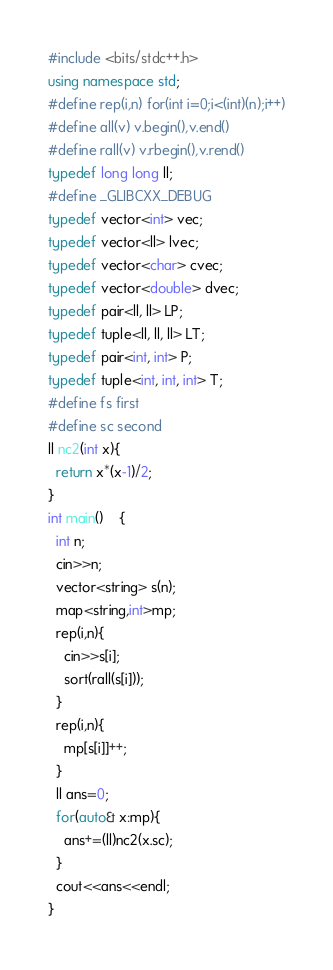<code> <loc_0><loc_0><loc_500><loc_500><_C++_>#include <bits/stdc++.h>
using namespace std;
#define rep(i,n) for(int i=0;i<(int)(n);i++)
#define all(v) v.begin(),v.end()
#define rall(v) v.rbegin(),v.rend()
typedef long long ll;
#define _GLIBCXX_DEBUG
typedef vector<int> vec;
typedef vector<ll> lvec;
typedef vector<char> cvec;
typedef vector<double> dvec;
typedef pair<ll, ll> LP;
typedef tuple<ll, ll, ll> LT;
typedef pair<int, int> P;
typedef tuple<int, int, int> T;
#define fs first
#define sc second
ll nc2(int x){
  return x*(x-1)/2;
}
int main()	{
  int n;
  cin>>n;
  vector<string> s(n);
  map<string,int>mp;
  rep(i,n){
    cin>>s[i];
    sort(rall(s[i]));
  }
  rep(i,n){
    mp[s[i]]++;
  }
  ll ans=0;
  for(auto& x:mp){
    ans+=(ll)nc2(x.sc);
  }
  cout<<ans<<endl;
}</code> 